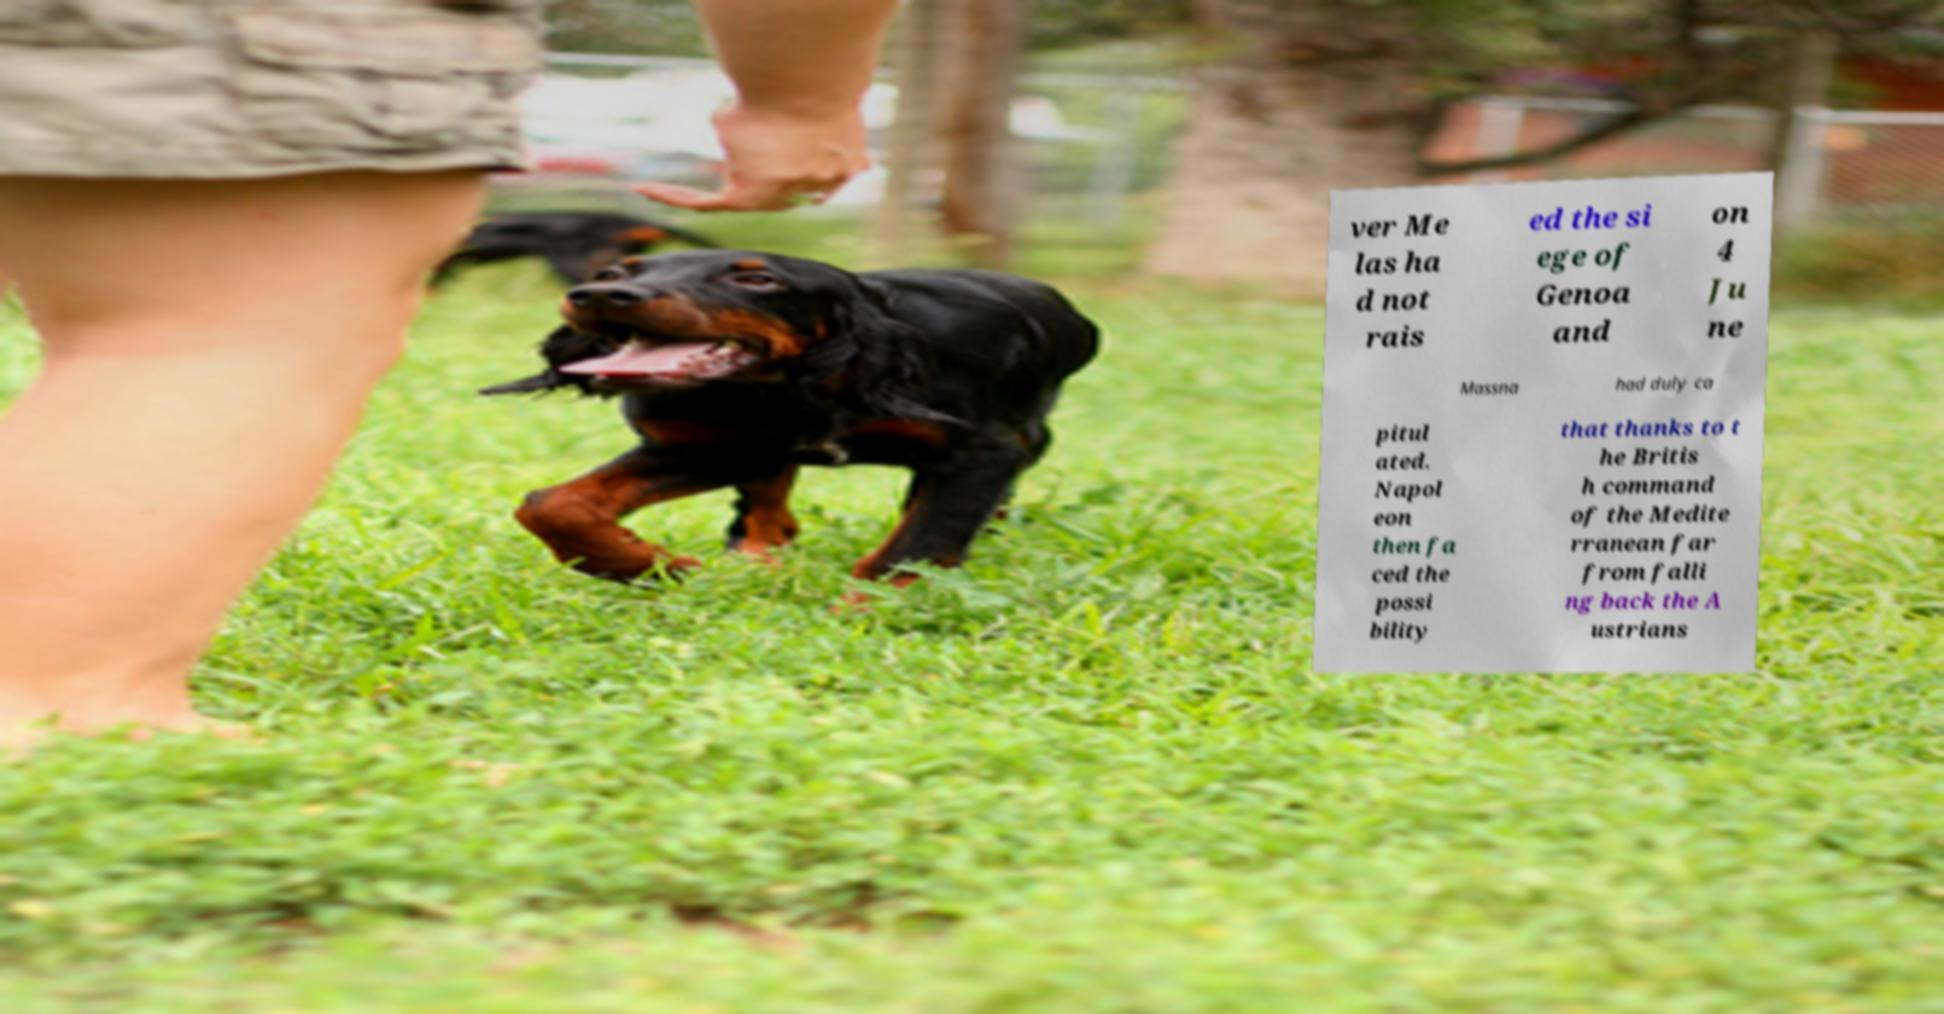Can you read and provide the text displayed in the image?This photo seems to have some interesting text. Can you extract and type it out for me? ver Me las ha d not rais ed the si ege of Genoa and on 4 Ju ne Massna had duly ca pitul ated. Napol eon then fa ced the possi bility that thanks to t he Britis h command of the Medite rranean far from falli ng back the A ustrians 